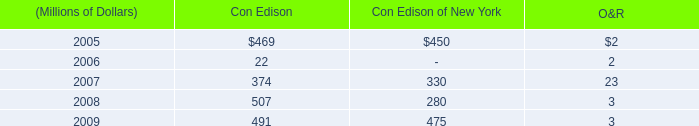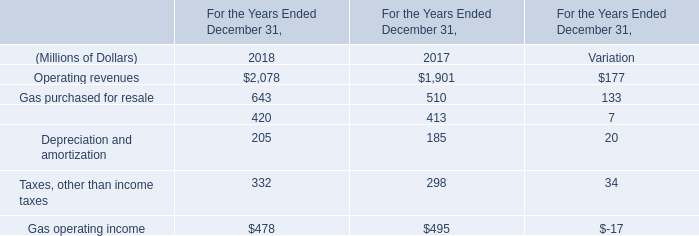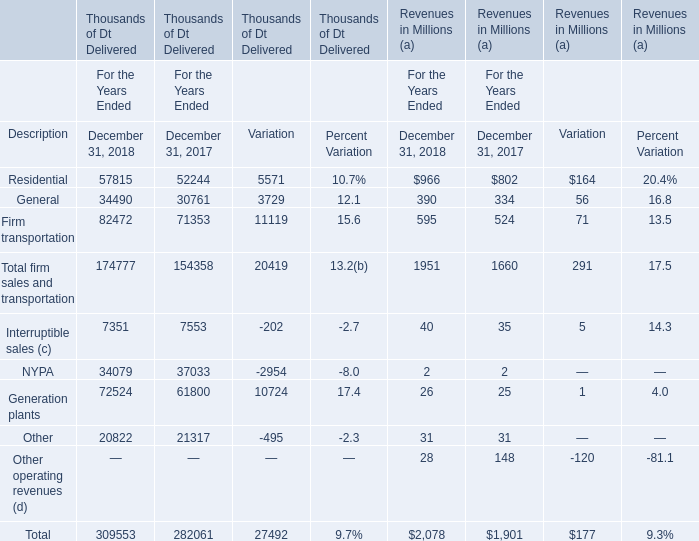How many kinds of Revenues are greater than 1000 in 2018? 
Answer: 1. 